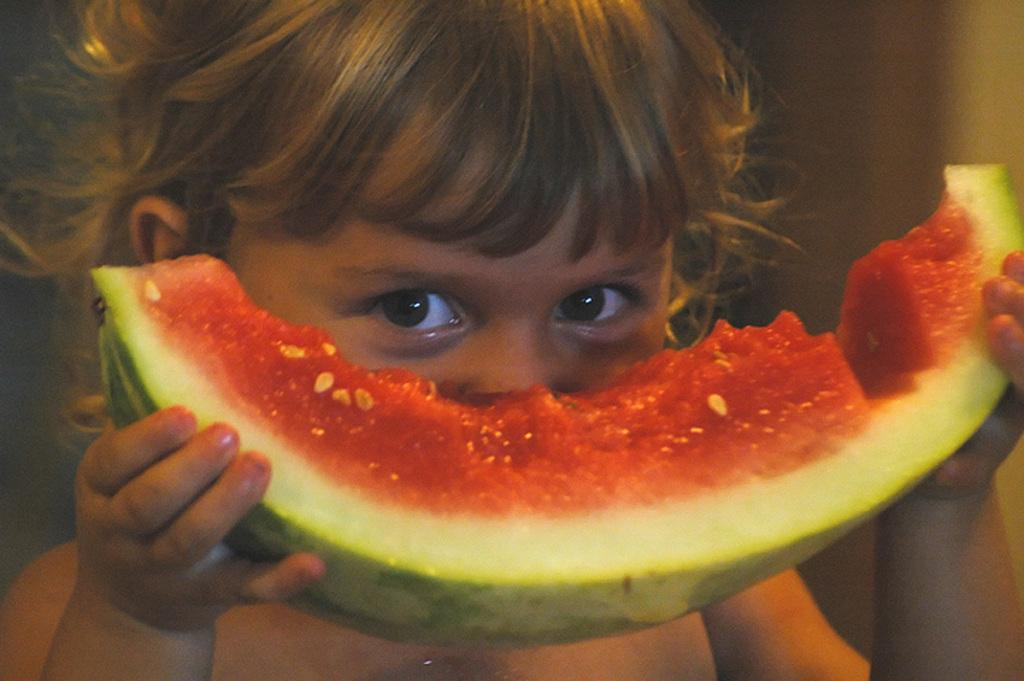Who is the main subject in the image? There is a girl in the image. What is the girl holding in the image? The girl is holding a slice of watermelon. What is the girl's facial expression or action in the image? The girl is looking at the camera. How would you describe the background of the image? The background of the image is blurred. Can you see any boats in the image? There are no boats present in the image. What type of ground is visible in the image? The image does not show any ground; it is focused on the girl and her surroundings. 